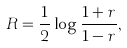Convert formula to latex. <formula><loc_0><loc_0><loc_500><loc_500>R = \frac { 1 } { 2 } \log \frac { 1 + r } { 1 - r } ,</formula> 